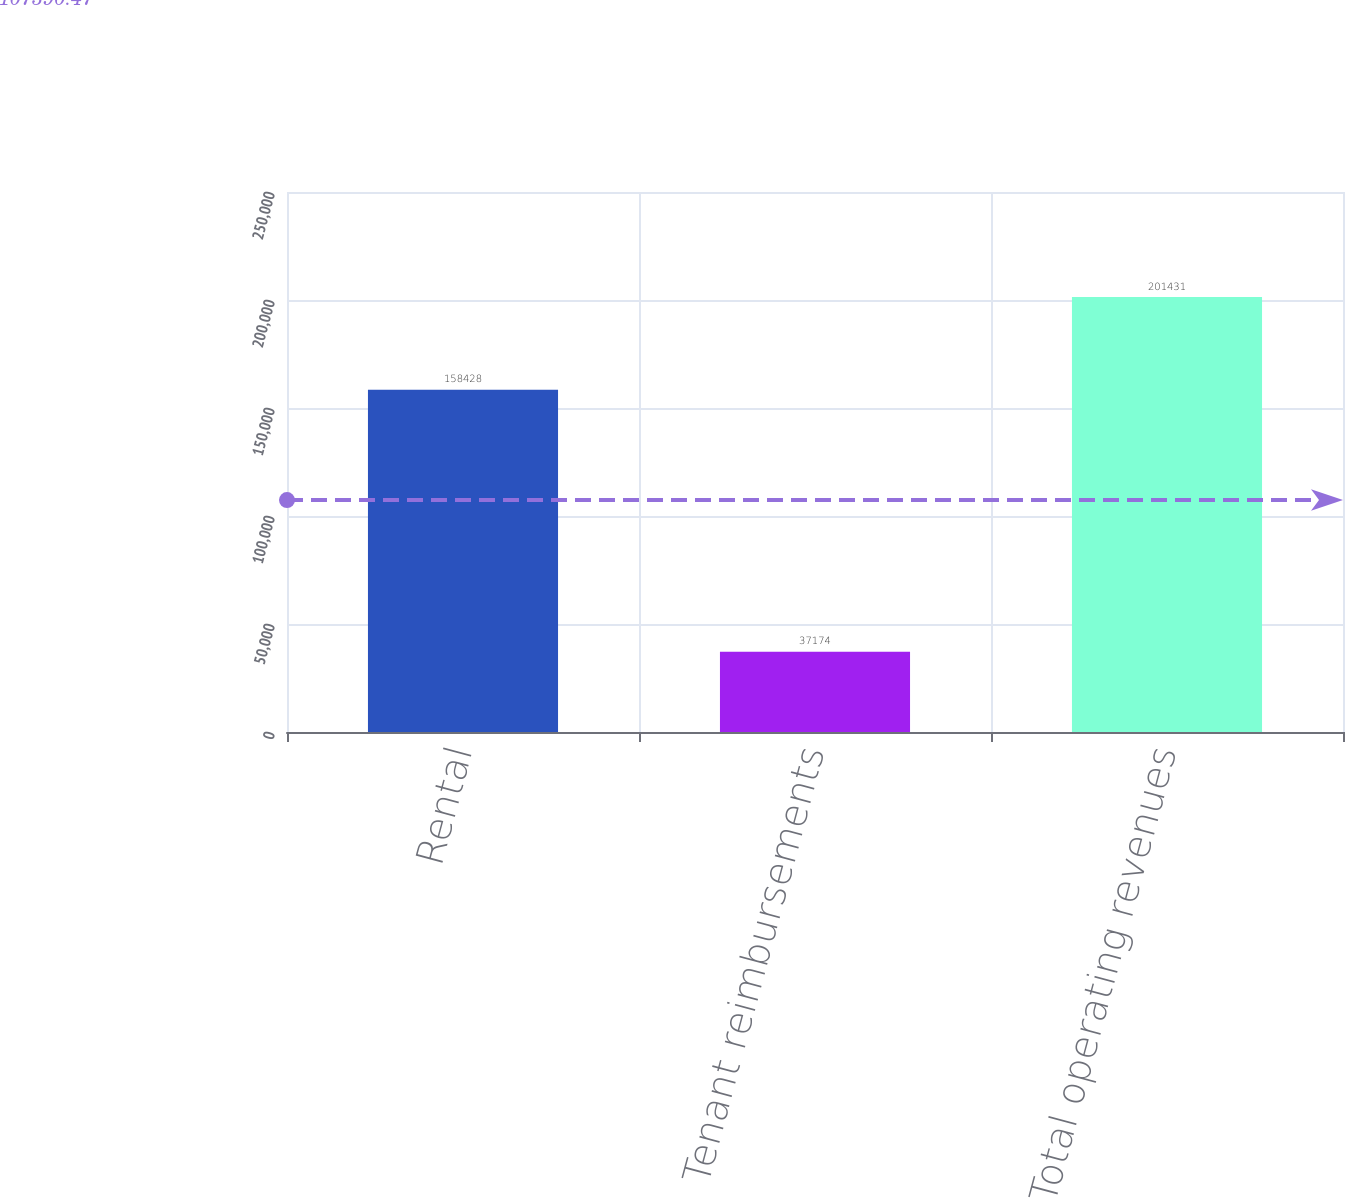Convert chart. <chart><loc_0><loc_0><loc_500><loc_500><bar_chart><fcel>Rental<fcel>Tenant reimbursements<fcel>Total operating revenues<nl><fcel>158428<fcel>37174<fcel>201431<nl></chart> 